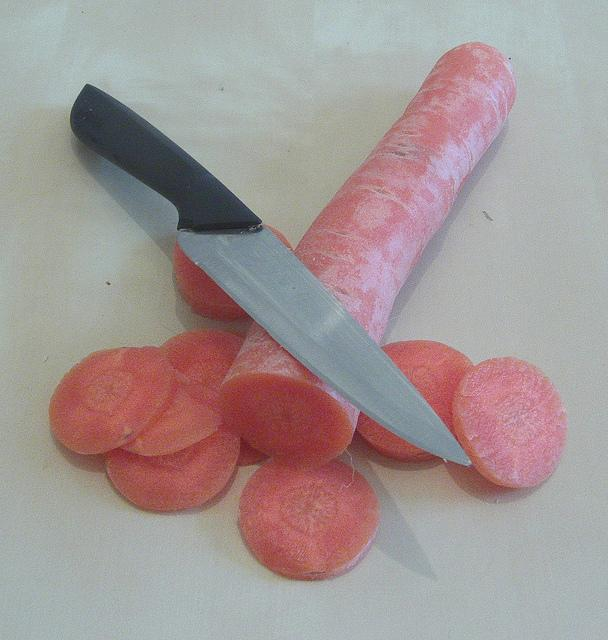What animal loves this food? rabbit 